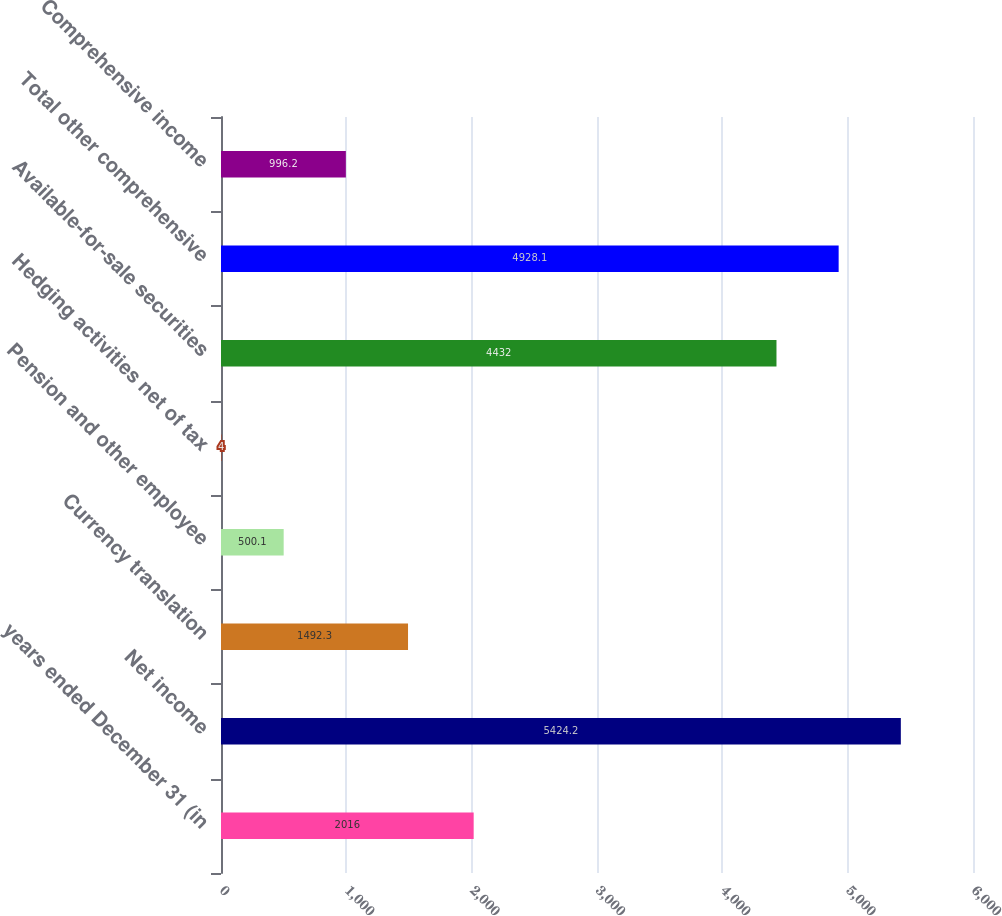Convert chart. <chart><loc_0><loc_0><loc_500><loc_500><bar_chart><fcel>years ended December 31 (in<fcel>Net income<fcel>Currency translation<fcel>Pension and other employee<fcel>Hedging activities net of tax<fcel>Available-for-sale securities<fcel>Total other comprehensive<fcel>Comprehensive income<nl><fcel>2016<fcel>5424.2<fcel>1492.3<fcel>500.1<fcel>4<fcel>4432<fcel>4928.1<fcel>996.2<nl></chart> 